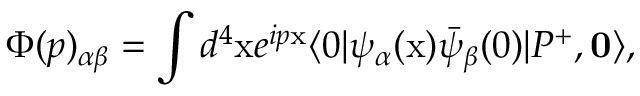Convert formula to latex. <formula><loc_0><loc_0><loc_500><loc_500>\Phi ( p ) _ { \alpha \beta } = \int d ^ { 4 } x e ^ { i p x } \langle 0 | \psi _ { \alpha } ( x ) \bar { \psi } _ { \beta } ( 0 ) | P ^ { + } , { 0 } \rangle ,</formula> 